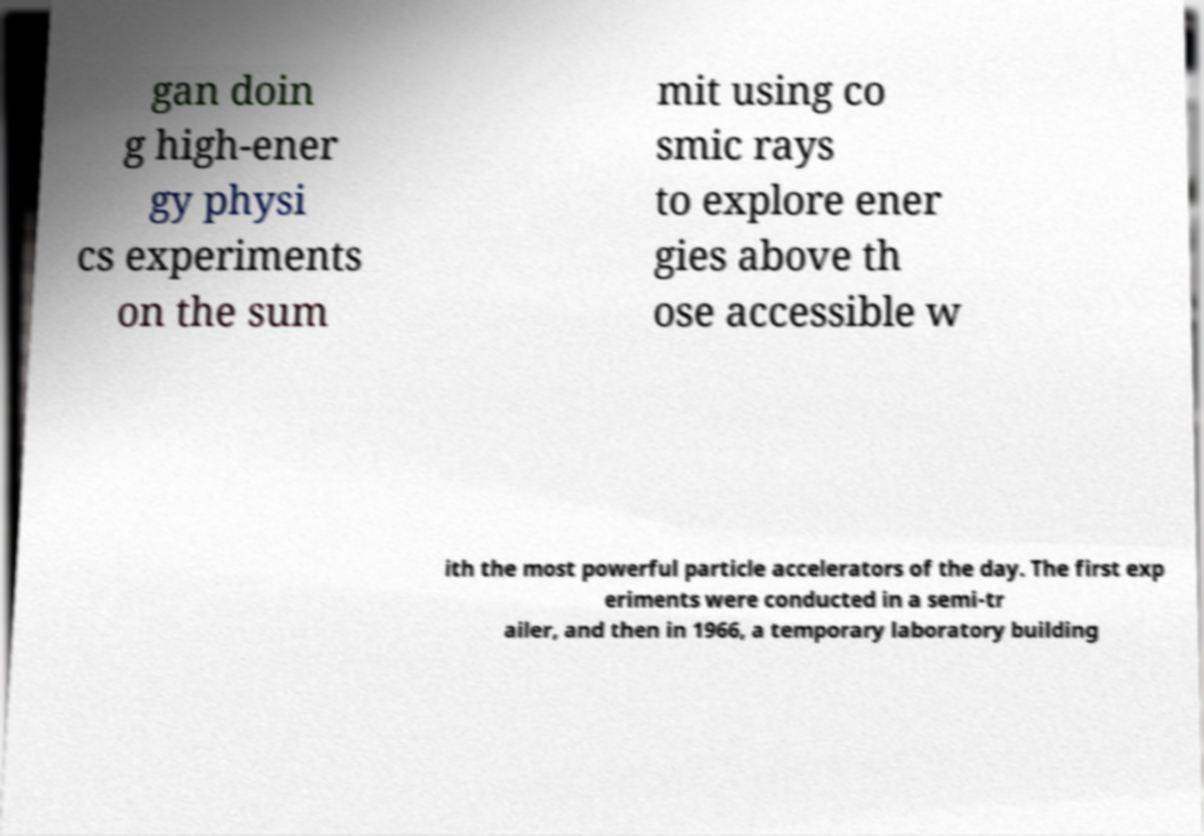Could you assist in decoding the text presented in this image and type it out clearly? gan doin g high-ener gy physi cs experiments on the sum mit using co smic rays to explore ener gies above th ose accessible w ith the most powerful particle accelerators of the day. The first exp eriments were conducted in a semi-tr ailer, and then in 1966, a temporary laboratory building 